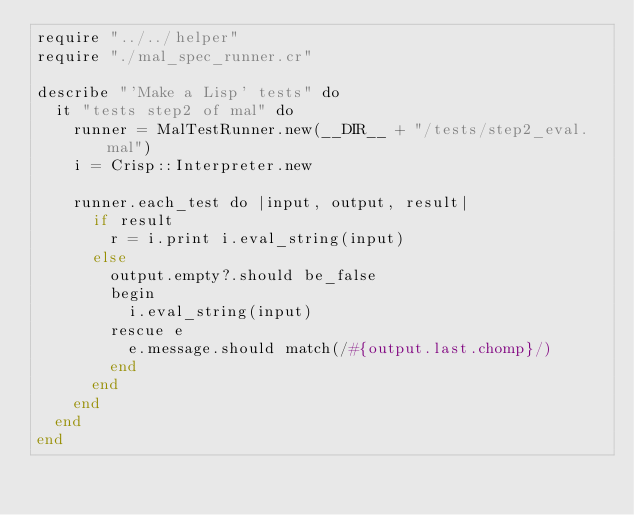<code> <loc_0><loc_0><loc_500><loc_500><_Crystal_>require "../../helper"
require "./mal_spec_runner.cr"

describe "'Make a Lisp' tests" do
  it "tests step2 of mal" do
    runner = MalTestRunner.new(__DIR__ + "/tests/step2_eval.mal")
    i = Crisp::Interpreter.new

    runner.each_test do |input, output, result|
      if result
        r = i.print i.eval_string(input)
      else
        output.empty?.should be_false
        begin
          i.eval_string(input)
        rescue e
          e.message.should match(/#{output.last.chomp}/)
        end
      end
    end
  end
end
</code> 